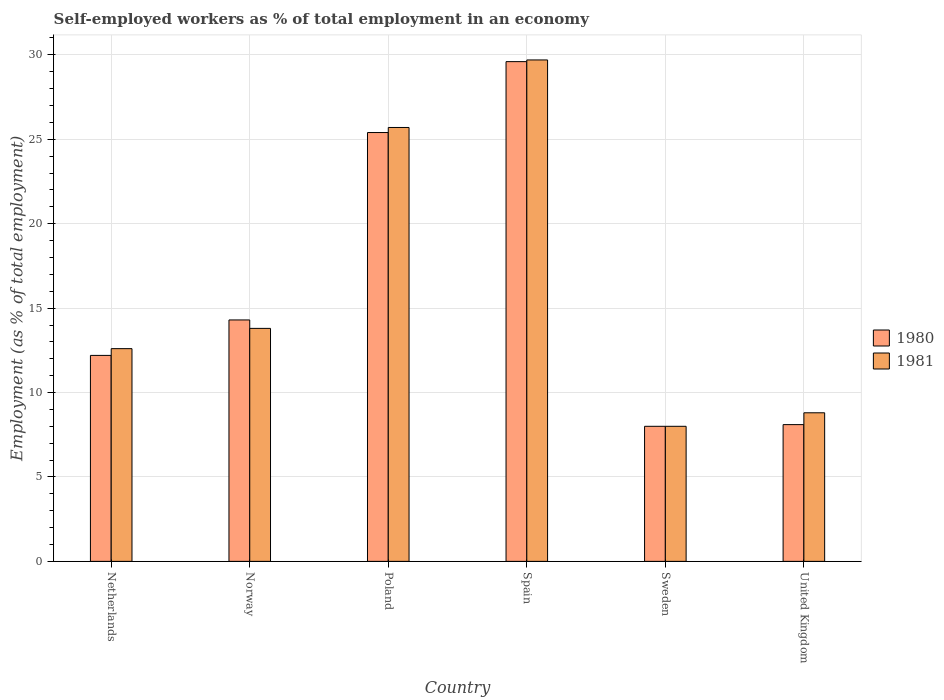Are the number of bars on each tick of the X-axis equal?
Your response must be concise. Yes. How many bars are there on the 3rd tick from the left?
Make the answer very short. 2. How many bars are there on the 6th tick from the right?
Ensure brevity in your answer.  2. Across all countries, what is the maximum percentage of self-employed workers in 1981?
Your answer should be compact. 29.7. In which country was the percentage of self-employed workers in 1980 maximum?
Ensure brevity in your answer.  Spain. What is the total percentage of self-employed workers in 1980 in the graph?
Your response must be concise. 97.6. What is the difference between the percentage of self-employed workers in 1981 in Netherlands and that in Norway?
Keep it short and to the point. -1.2. What is the difference between the percentage of self-employed workers in 1981 in Sweden and the percentage of self-employed workers in 1980 in Spain?
Ensure brevity in your answer.  -21.6. What is the average percentage of self-employed workers in 1981 per country?
Offer a terse response. 16.43. In how many countries, is the percentage of self-employed workers in 1980 greater than 7 %?
Ensure brevity in your answer.  6. What is the ratio of the percentage of self-employed workers in 1981 in Netherlands to that in Sweden?
Provide a succinct answer. 1.58. Is the difference between the percentage of self-employed workers in 1981 in Netherlands and Poland greater than the difference between the percentage of self-employed workers in 1980 in Netherlands and Poland?
Your answer should be very brief. Yes. What is the difference between the highest and the second highest percentage of self-employed workers in 1981?
Make the answer very short. 11.9. What is the difference between the highest and the lowest percentage of self-employed workers in 1980?
Offer a terse response. 21.6. Are all the bars in the graph horizontal?
Ensure brevity in your answer.  No. What is the difference between two consecutive major ticks on the Y-axis?
Keep it short and to the point. 5. What is the title of the graph?
Offer a terse response. Self-employed workers as % of total employment in an economy. Does "2003" appear as one of the legend labels in the graph?
Your answer should be very brief. No. What is the label or title of the Y-axis?
Ensure brevity in your answer.  Employment (as % of total employment). What is the Employment (as % of total employment) in 1980 in Netherlands?
Your response must be concise. 12.2. What is the Employment (as % of total employment) of 1981 in Netherlands?
Your answer should be very brief. 12.6. What is the Employment (as % of total employment) of 1980 in Norway?
Your response must be concise. 14.3. What is the Employment (as % of total employment) of 1981 in Norway?
Your response must be concise. 13.8. What is the Employment (as % of total employment) of 1980 in Poland?
Provide a succinct answer. 25.4. What is the Employment (as % of total employment) in 1981 in Poland?
Your answer should be very brief. 25.7. What is the Employment (as % of total employment) in 1980 in Spain?
Give a very brief answer. 29.6. What is the Employment (as % of total employment) in 1981 in Spain?
Provide a short and direct response. 29.7. What is the Employment (as % of total employment) of 1980 in Sweden?
Make the answer very short. 8. What is the Employment (as % of total employment) in 1981 in Sweden?
Provide a succinct answer. 8. What is the Employment (as % of total employment) of 1980 in United Kingdom?
Keep it short and to the point. 8.1. What is the Employment (as % of total employment) in 1981 in United Kingdom?
Provide a succinct answer. 8.8. Across all countries, what is the maximum Employment (as % of total employment) of 1980?
Offer a terse response. 29.6. Across all countries, what is the maximum Employment (as % of total employment) in 1981?
Ensure brevity in your answer.  29.7. Across all countries, what is the minimum Employment (as % of total employment) of 1980?
Give a very brief answer. 8. What is the total Employment (as % of total employment) of 1980 in the graph?
Offer a very short reply. 97.6. What is the total Employment (as % of total employment) in 1981 in the graph?
Make the answer very short. 98.6. What is the difference between the Employment (as % of total employment) in 1980 in Netherlands and that in Norway?
Offer a very short reply. -2.1. What is the difference between the Employment (as % of total employment) of 1980 in Netherlands and that in Poland?
Your answer should be compact. -13.2. What is the difference between the Employment (as % of total employment) in 1981 in Netherlands and that in Poland?
Offer a very short reply. -13.1. What is the difference between the Employment (as % of total employment) in 1980 in Netherlands and that in Spain?
Ensure brevity in your answer.  -17.4. What is the difference between the Employment (as % of total employment) of 1981 in Netherlands and that in Spain?
Your response must be concise. -17.1. What is the difference between the Employment (as % of total employment) in 1980 in Netherlands and that in Sweden?
Keep it short and to the point. 4.2. What is the difference between the Employment (as % of total employment) of 1981 in Netherlands and that in Sweden?
Provide a succinct answer. 4.6. What is the difference between the Employment (as % of total employment) in 1980 in Netherlands and that in United Kingdom?
Ensure brevity in your answer.  4.1. What is the difference between the Employment (as % of total employment) in 1981 in Netherlands and that in United Kingdom?
Keep it short and to the point. 3.8. What is the difference between the Employment (as % of total employment) of 1980 in Norway and that in Poland?
Ensure brevity in your answer.  -11.1. What is the difference between the Employment (as % of total employment) of 1981 in Norway and that in Poland?
Provide a succinct answer. -11.9. What is the difference between the Employment (as % of total employment) in 1980 in Norway and that in Spain?
Make the answer very short. -15.3. What is the difference between the Employment (as % of total employment) of 1981 in Norway and that in Spain?
Provide a short and direct response. -15.9. What is the difference between the Employment (as % of total employment) in 1980 in Norway and that in Sweden?
Provide a succinct answer. 6.3. What is the difference between the Employment (as % of total employment) in 1981 in Norway and that in Sweden?
Your answer should be very brief. 5.8. What is the difference between the Employment (as % of total employment) in 1981 in Norway and that in United Kingdom?
Give a very brief answer. 5. What is the difference between the Employment (as % of total employment) in 1980 in Poland and that in Spain?
Make the answer very short. -4.2. What is the difference between the Employment (as % of total employment) of 1981 in Poland and that in Sweden?
Keep it short and to the point. 17.7. What is the difference between the Employment (as % of total employment) of 1981 in Poland and that in United Kingdom?
Ensure brevity in your answer.  16.9. What is the difference between the Employment (as % of total employment) of 1980 in Spain and that in Sweden?
Provide a succinct answer. 21.6. What is the difference between the Employment (as % of total employment) in 1981 in Spain and that in Sweden?
Provide a short and direct response. 21.7. What is the difference between the Employment (as % of total employment) of 1981 in Spain and that in United Kingdom?
Your response must be concise. 20.9. What is the difference between the Employment (as % of total employment) in 1980 in Sweden and that in United Kingdom?
Offer a terse response. -0.1. What is the difference between the Employment (as % of total employment) in 1981 in Sweden and that in United Kingdom?
Ensure brevity in your answer.  -0.8. What is the difference between the Employment (as % of total employment) of 1980 in Netherlands and the Employment (as % of total employment) of 1981 in Spain?
Keep it short and to the point. -17.5. What is the difference between the Employment (as % of total employment) in 1980 in Norway and the Employment (as % of total employment) in 1981 in Poland?
Make the answer very short. -11.4. What is the difference between the Employment (as % of total employment) of 1980 in Norway and the Employment (as % of total employment) of 1981 in Spain?
Provide a short and direct response. -15.4. What is the difference between the Employment (as % of total employment) of 1980 in Poland and the Employment (as % of total employment) of 1981 in Sweden?
Your response must be concise. 17.4. What is the difference between the Employment (as % of total employment) of 1980 in Poland and the Employment (as % of total employment) of 1981 in United Kingdom?
Offer a very short reply. 16.6. What is the difference between the Employment (as % of total employment) in 1980 in Spain and the Employment (as % of total employment) in 1981 in Sweden?
Your answer should be compact. 21.6. What is the difference between the Employment (as % of total employment) in 1980 in Spain and the Employment (as % of total employment) in 1981 in United Kingdom?
Provide a short and direct response. 20.8. What is the difference between the Employment (as % of total employment) in 1980 in Sweden and the Employment (as % of total employment) in 1981 in United Kingdom?
Offer a very short reply. -0.8. What is the average Employment (as % of total employment) of 1980 per country?
Your response must be concise. 16.27. What is the average Employment (as % of total employment) in 1981 per country?
Give a very brief answer. 16.43. What is the difference between the Employment (as % of total employment) of 1980 and Employment (as % of total employment) of 1981 in Netherlands?
Keep it short and to the point. -0.4. What is the difference between the Employment (as % of total employment) of 1980 and Employment (as % of total employment) of 1981 in Spain?
Provide a short and direct response. -0.1. What is the difference between the Employment (as % of total employment) in 1980 and Employment (as % of total employment) in 1981 in Sweden?
Make the answer very short. 0. What is the difference between the Employment (as % of total employment) of 1980 and Employment (as % of total employment) of 1981 in United Kingdom?
Your response must be concise. -0.7. What is the ratio of the Employment (as % of total employment) in 1980 in Netherlands to that in Norway?
Offer a terse response. 0.85. What is the ratio of the Employment (as % of total employment) in 1981 in Netherlands to that in Norway?
Offer a terse response. 0.91. What is the ratio of the Employment (as % of total employment) in 1980 in Netherlands to that in Poland?
Your answer should be compact. 0.48. What is the ratio of the Employment (as % of total employment) in 1981 in Netherlands to that in Poland?
Ensure brevity in your answer.  0.49. What is the ratio of the Employment (as % of total employment) in 1980 in Netherlands to that in Spain?
Keep it short and to the point. 0.41. What is the ratio of the Employment (as % of total employment) of 1981 in Netherlands to that in Spain?
Provide a succinct answer. 0.42. What is the ratio of the Employment (as % of total employment) in 1980 in Netherlands to that in Sweden?
Offer a terse response. 1.52. What is the ratio of the Employment (as % of total employment) of 1981 in Netherlands to that in Sweden?
Offer a terse response. 1.57. What is the ratio of the Employment (as % of total employment) in 1980 in Netherlands to that in United Kingdom?
Your answer should be compact. 1.51. What is the ratio of the Employment (as % of total employment) in 1981 in Netherlands to that in United Kingdom?
Keep it short and to the point. 1.43. What is the ratio of the Employment (as % of total employment) of 1980 in Norway to that in Poland?
Provide a short and direct response. 0.56. What is the ratio of the Employment (as % of total employment) of 1981 in Norway to that in Poland?
Provide a succinct answer. 0.54. What is the ratio of the Employment (as % of total employment) of 1980 in Norway to that in Spain?
Provide a succinct answer. 0.48. What is the ratio of the Employment (as % of total employment) in 1981 in Norway to that in Spain?
Ensure brevity in your answer.  0.46. What is the ratio of the Employment (as % of total employment) in 1980 in Norway to that in Sweden?
Your response must be concise. 1.79. What is the ratio of the Employment (as % of total employment) in 1981 in Norway to that in Sweden?
Give a very brief answer. 1.73. What is the ratio of the Employment (as % of total employment) in 1980 in Norway to that in United Kingdom?
Your response must be concise. 1.77. What is the ratio of the Employment (as % of total employment) in 1981 in Norway to that in United Kingdom?
Your response must be concise. 1.57. What is the ratio of the Employment (as % of total employment) of 1980 in Poland to that in Spain?
Your answer should be compact. 0.86. What is the ratio of the Employment (as % of total employment) of 1981 in Poland to that in Spain?
Your answer should be very brief. 0.87. What is the ratio of the Employment (as % of total employment) of 1980 in Poland to that in Sweden?
Your response must be concise. 3.17. What is the ratio of the Employment (as % of total employment) of 1981 in Poland to that in Sweden?
Provide a short and direct response. 3.21. What is the ratio of the Employment (as % of total employment) of 1980 in Poland to that in United Kingdom?
Make the answer very short. 3.14. What is the ratio of the Employment (as % of total employment) in 1981 in Poland to that in United Kingdom?
Offer a terse response. 2.92. What is the ratio of the Employment (as % of total employment) of 1981 in Spain to that in Sweden?
Provide a succinct answer. 3.71. What is the ratio of the Employment (as % of total employment) in 1980 in Spain to that in United Kingdom?
Your answer should be very brief. 3.65. What is the ratio of the Employment (as % of total employment) of 1981 in Spain to that in United Kingdom?
Keep it short and to the point. 3.38. What is the difference between the highest and the second highest Employment (as % of total employment) in 1980?
Your answer should be compact. 4.2. What is the difference between the highest and the second highest Employment (as % of total employment) of 1981?
Ensure brevity in your answer.  4. What is the difference between the highest and the lowest Employment (as % of total employment) of 1980?
Make the answer very short. 21.6. What is the difference between the highest and the lowest Employment (as % of total employment) of 1981?
Your answer should be very brief. 21.7. 